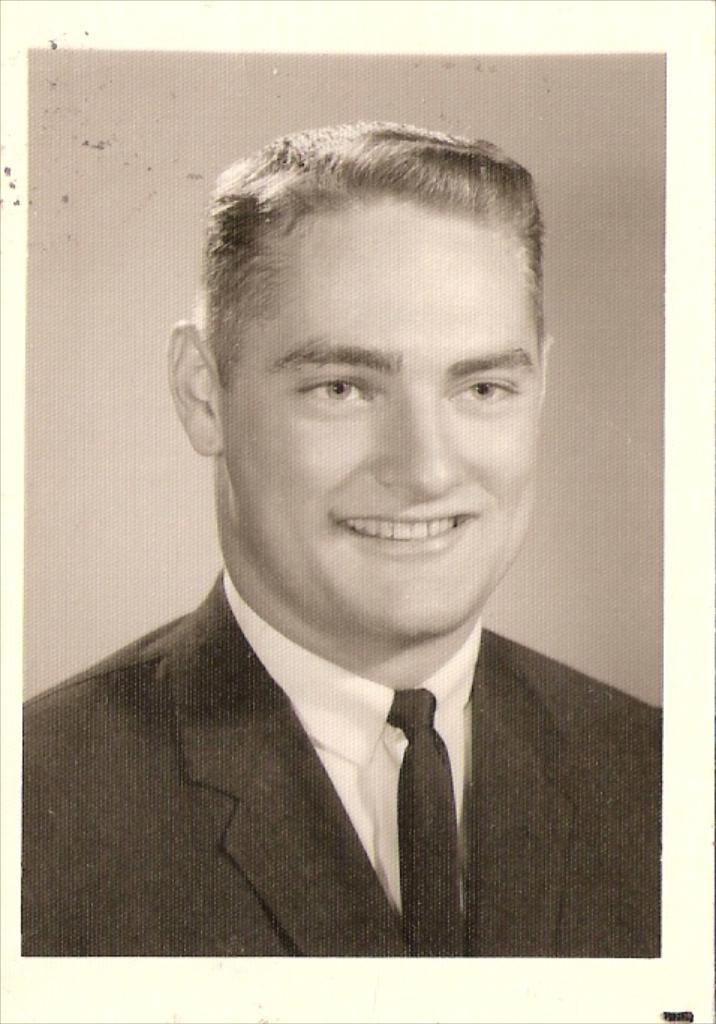How would you summarize this image in a sentence or two? This is a black and white picture, in this image we can see a photo of a person smiling and wearing the suit. 